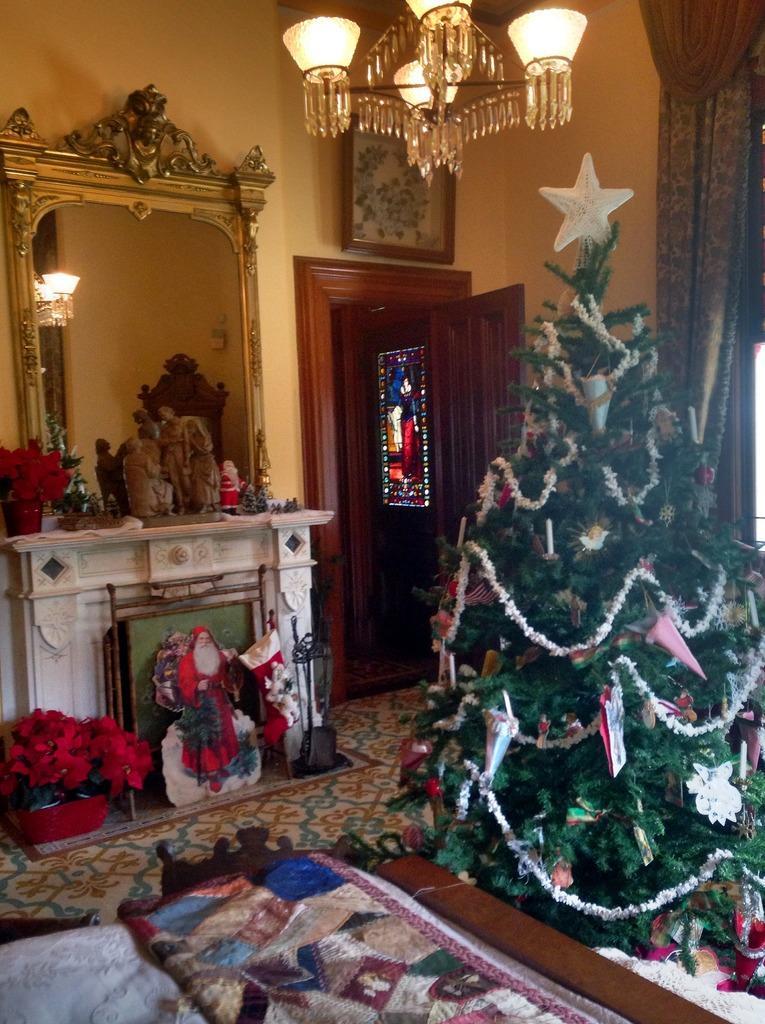Can you describe this image briefly? This image is inside a room where we can see blanket on the bed, we can see the Christmas tree, flower pots, fireplace, idols, mirror, chandelier, door, photo frame on the wall, curtains and stained glass window in the background. 